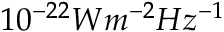Convert formula to latex. <formula><loc_0><loc_0><loc_500><loc_500>1 0 ^ { - 2 2 } W m ^ { - 2 } H z ^ { - 1 }</formula> 